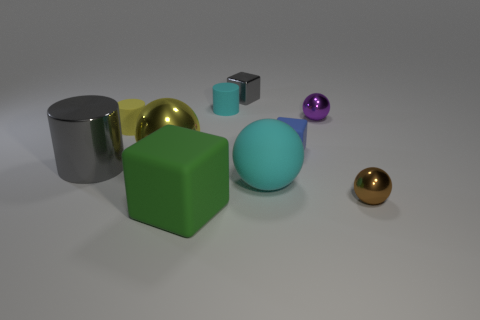Subtract all gray spheres. Subtract all purple cylinders. How many spheres are left? 4 Subtract all cylinders. How many objects are left? 7 Subtract all big metal cylinders. Subtract all tiny purple shiny objects. How many objects are left? 8 Add 4 tiny cylinders. How many tiny cylinders are left? 6 Add 1 rubber cylinders. How many rubber cylinders exist? 3 Subtract 1 brown spheres. How many objects are left? 9 